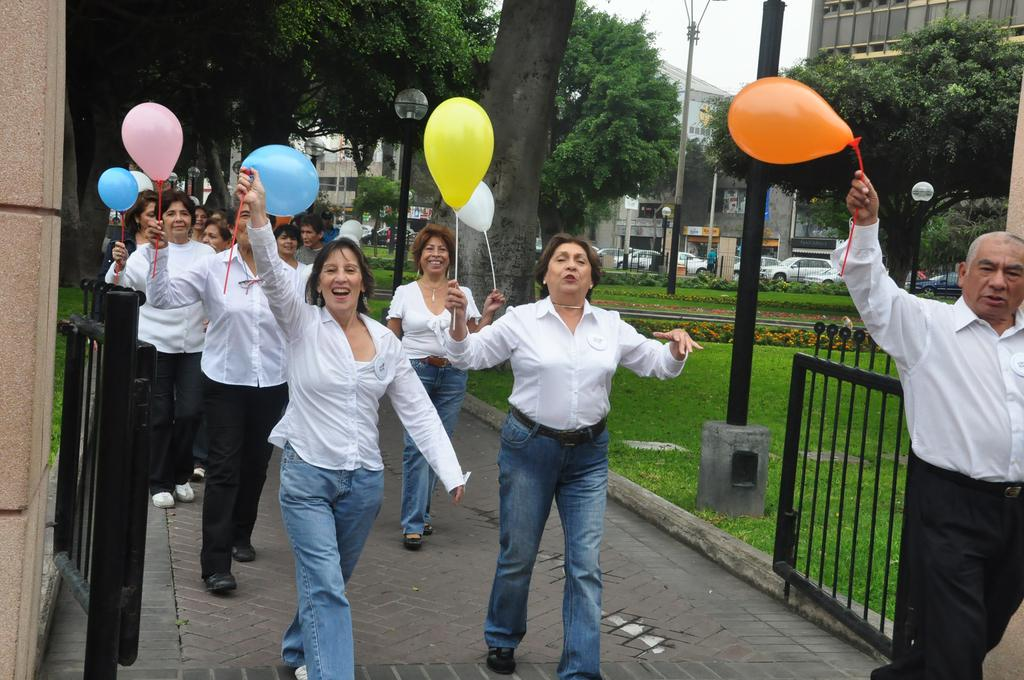What are the people in the image doing? The people in the image are walking on a path. What are the people holding while walking? The people are holding balloons. What are the people wearing that can be easily identified? The people are wearing white shirts. What can be seen in the background of the image? There are trees and buildings visible in the background of the image. What type of tooth is visible in the image? There is no tooth present in the image. How is the power being generated in the image? There is no power generation visible in the image. 